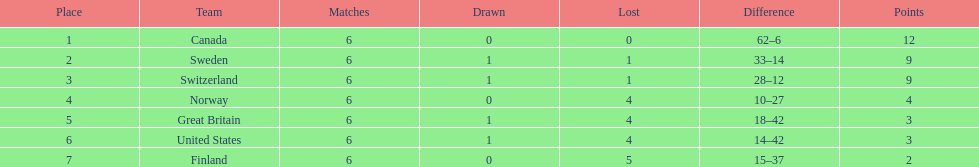What team placed after canada? Sweden. 